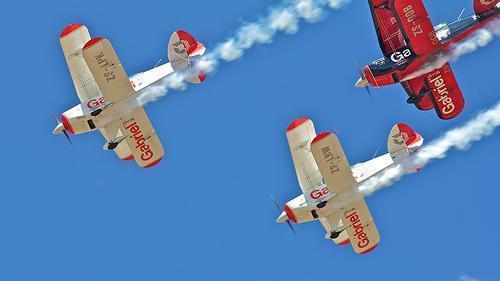How many planes are there?
Give a very brief answer. 3. 